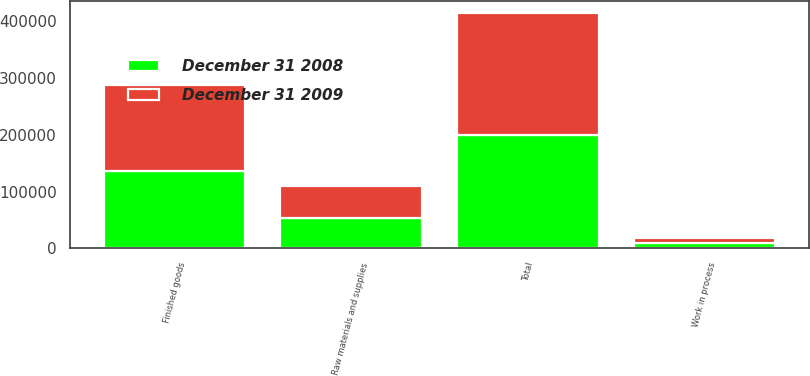<chart> <loc_0><loc_0><loc_500><loc_500><stacked_bar_chart><ecel><fcel>Raw materials and supplies<fcel>Work in process<fcel>Finished goods<fcel>Total<nl><fcel>December 31 2009<fcel>57305<fcel>9141<fcel>150424<fcel>216870<nl><fcel>December 31 2008<fcel>52850<fcel>9147<fcel>136896<fcel>198893<nl></chart> 